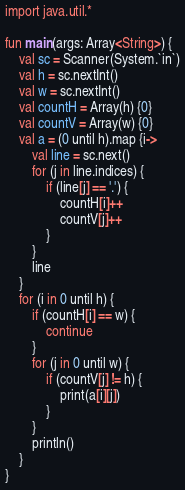<code> <loc_0><loc_0><loc_500><loc_500><_Kotlin_>import java.util.*

fun main(args: Array<String>) {
    val sc = Scanner(System.`in`)
    val h = sc.nextInt()
    val w = sc.nextInt()
    val countH = Array(h) {0}
    val countV = Array(w) {0}
    val a = (0 until h).map {i->
        val line = sc.next()
        for (j in line.indices) {
            if (line[j] == '.') {
                countH[i]++
                countV[j]++
            }
        }
        line
    }
    for (i in 0 until h) {
        if (countH[i] == w) {
            continue
        }
        for (j in 0 until w) {
            if (countV[j] != h) {
                print(a[i][j])
            }
        }
        println()
    }
}</code> 